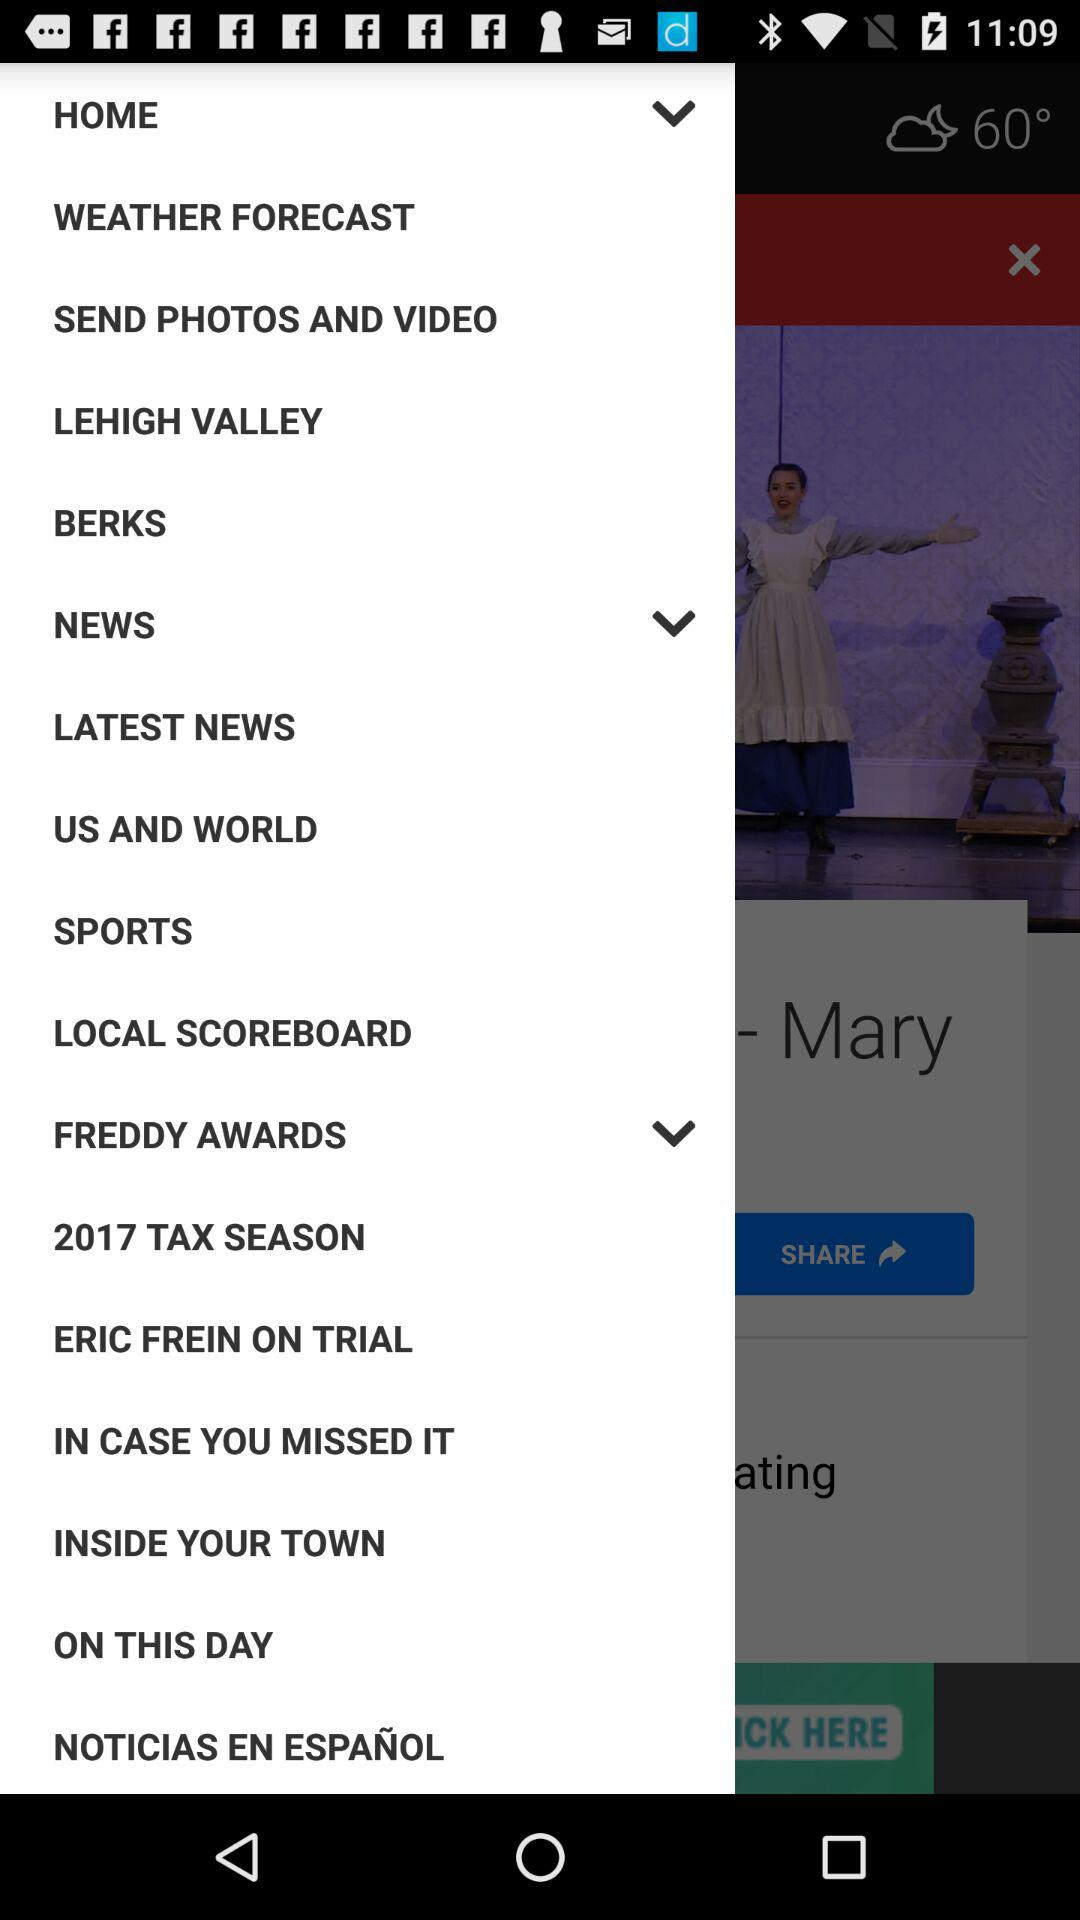What is the year for tax? The year of tax is 2017. 